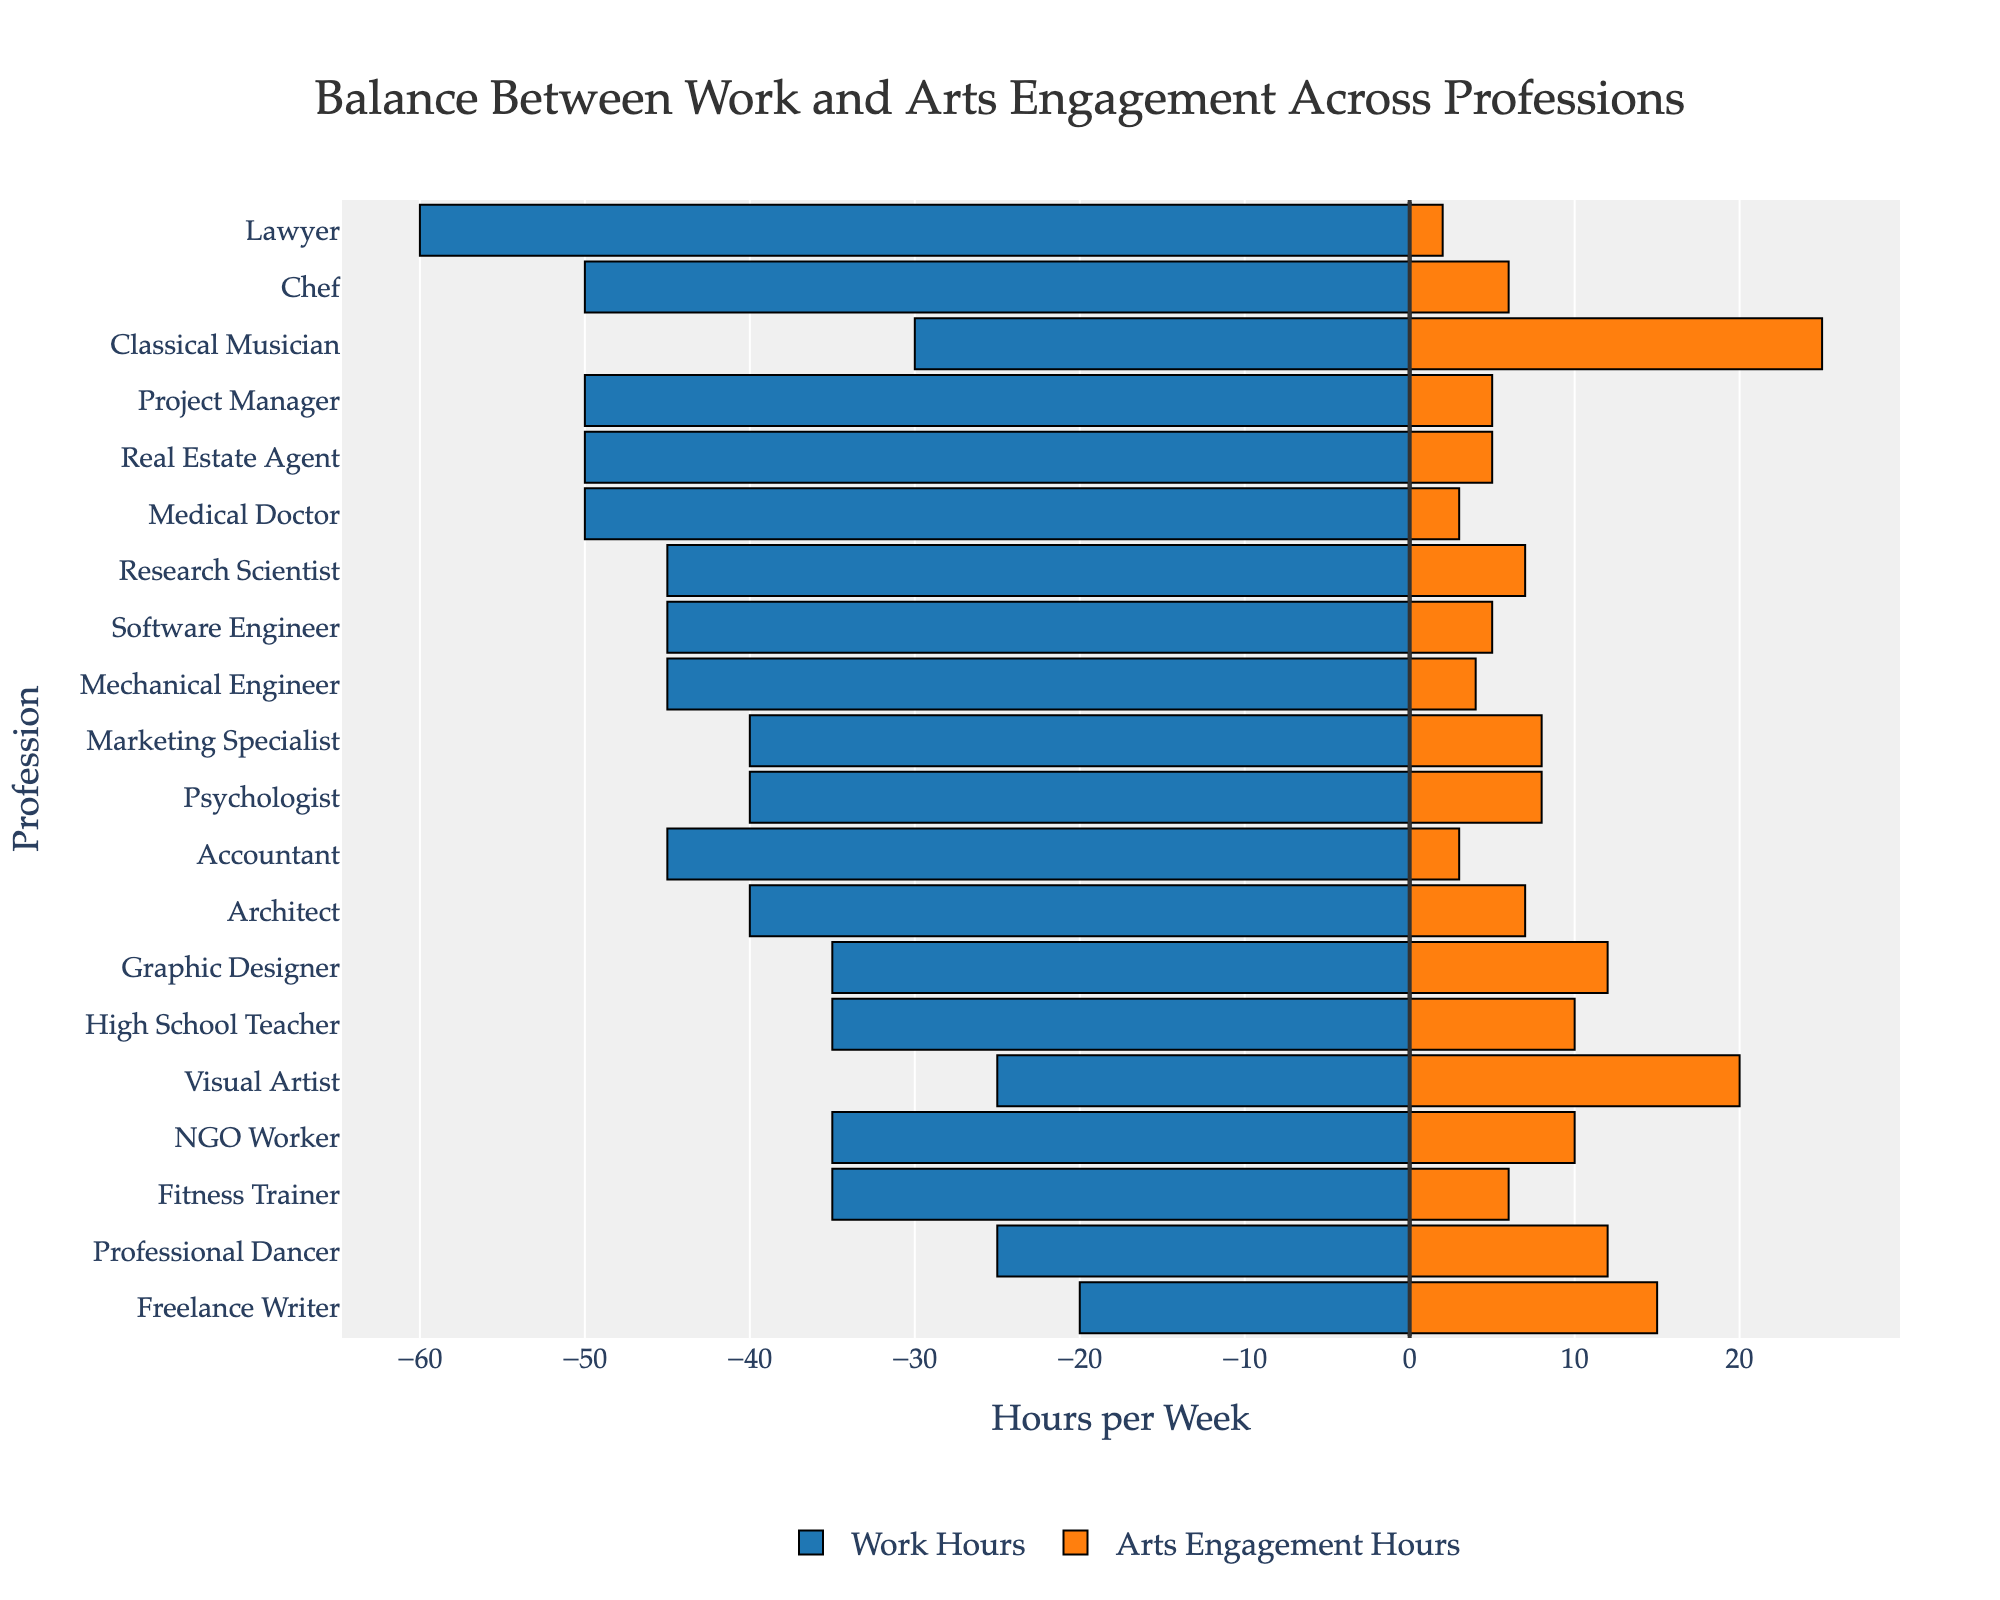what is the total amount of hours spent on work and arts engagement by a lawyer? To find the total hours for a lawyer, sum the work hours and arts engagement hours: 60 (work) + 2 (arts) = 62.
Answer: 62 hours Which profession dedicates the most hours to arts engagement? By looking at the bar lengths for arts engagement, the classical musician category has the longest bar, implying most hours spent in arts engagement (25 hours).
Answer: Classical Musician Comparing a software engineer to an architect, who spends more time on arts engagement and by how many hours? Compare the arts engagement hours: software engineer (5 hours) and architect (7 hours). Architect spends 2 more hours.
Answer: Architect, 2 hours Which profession has the closest balance between work and arts engagement hours? Check the profession with the smallest difference between work and arts engagement hours visually. Classical Musician with a difference of 5 hours (30 work and 25 arts), has the closest balance.
Answer: Classical Musician What's the combined total of work and arts engagement hours for freelance writers and graphic designers? Sum the total hours for both: Freelance Writer (20 work + 15 arts = 35), Graphic Designer (35 work + 12 arts = 47). Combined they are 35 + 47 = 82.
Answer: 82 hours Who spends more time on work: a project manager or a medical doctor? Compare the work hours: Project Manager (50 hours) and Medical Doctor (50 hours). Both spend the same amount of time.
Answer: Both spend the same amount of time Is the amount of arts engagement for a fitness trainer more or less than the arts engagement for a psychologist? Compare arts engagement hours: Fitness Trainer (6 hours) and Psychologist (8 hours). The fitness trainer spends less time in arts engagement.
Answer: Less Which profession has the highest total number of hours spent on work alone? Identify the profession with the longest blue bar representing work hours. The Lawyer has the highest with 60 hours.
Answer: Lawyer 